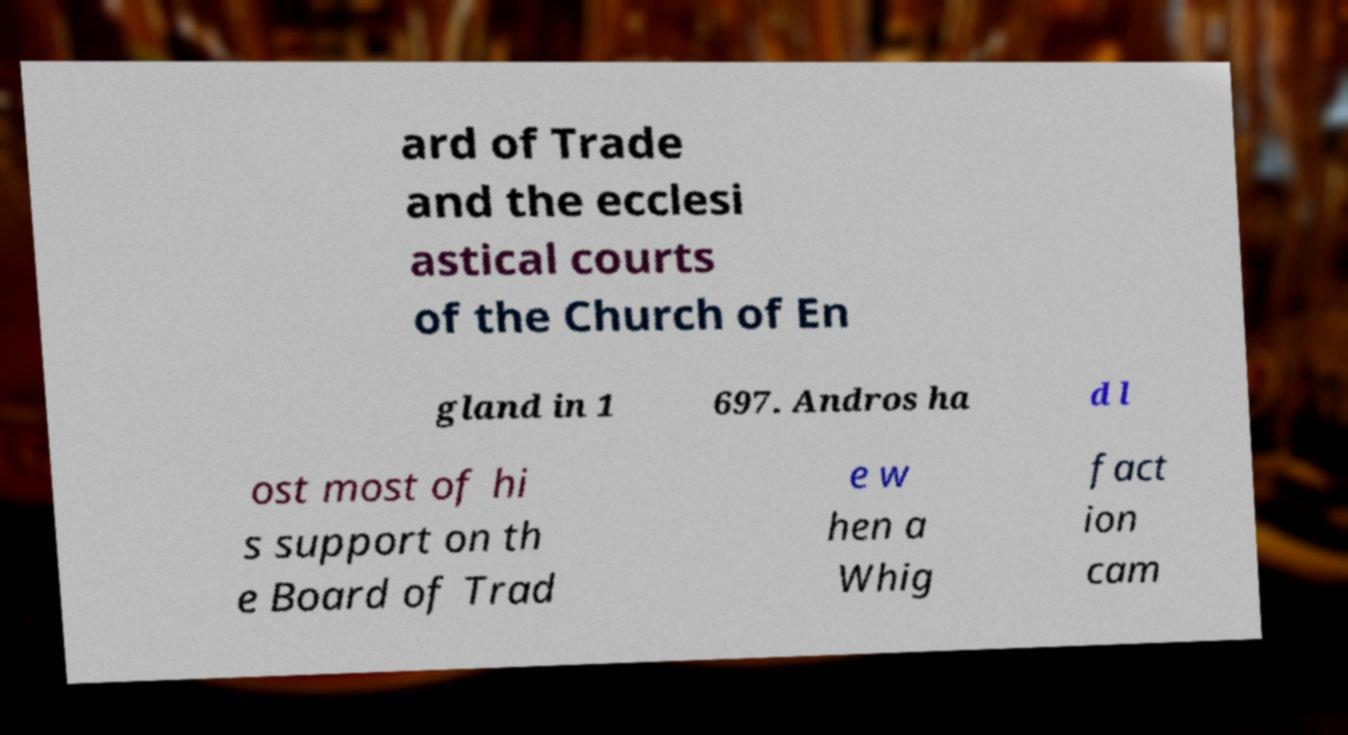What messages or text are displayed in this image? I need them in a readable, typed format. ard of Trade and the ecclesi astical courts of the Church of En gland in 1 697. Andros ha d l ost most of hi s support on th e Board of Trad e w hen a Whig fact ion cam 